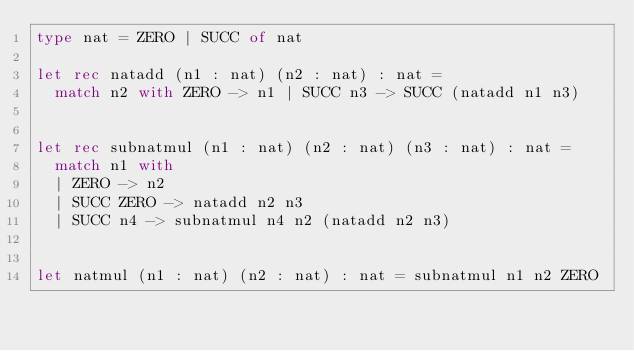Convert code to text. <code><loc_0><loc_0><loc_500><loc_500><_OCaml_>type nat = ZERO | SUCC of nat

let rec natadd (n1 : nat) (n2 : nat) : nat =
  match n2 with ZERO -> n1 | SUCC n3 -> SUCC (natadd n1 n3)


let rec subnatmul (n1 : nat) (n2 : nat) (n3 : nat) : nat =
  match n1 with
  | ZERO -> n2
  | SUCC ZERO -> natadd n2 n3
  | SUCC n4 -> subnatmul n4 n2 (natadd n2 n3)


let natmul (n1 : nat) (n2 : nat) : nat = subnatmul n1 n2 ZERO
</code> 